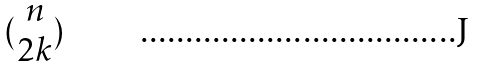<formula> <loc_0><loc_0><loc_500><loc_500>( \begin{matrix} n \\ 2 k \end{matrix} )</formula> 